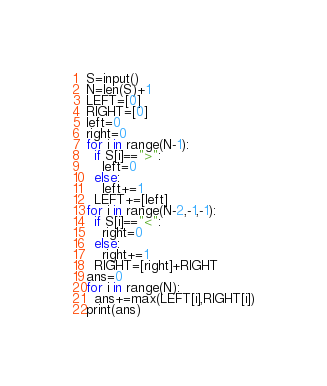Convert code to text. <code><loc_0><loc_0><loc_500><loc_500><_Python_>S=input()
N=len(S)+1
LEFT=[0]
RIGHT=[0]
left=0
right=0
for i in range(N-1):
  if S[i]==">":
    left=0
  else:
    left+=1
  LEFT+=[left]
for i in range(N-2,-1,-1):
  if S[i]=="<":
    right=0
  else:
    right+=1
  RIGHT=[right]+RIGHT
ans=0  
for i in range(N):  
  ans+=max(LEFT[i],RIGHT[i])
print(ans)  </code> 